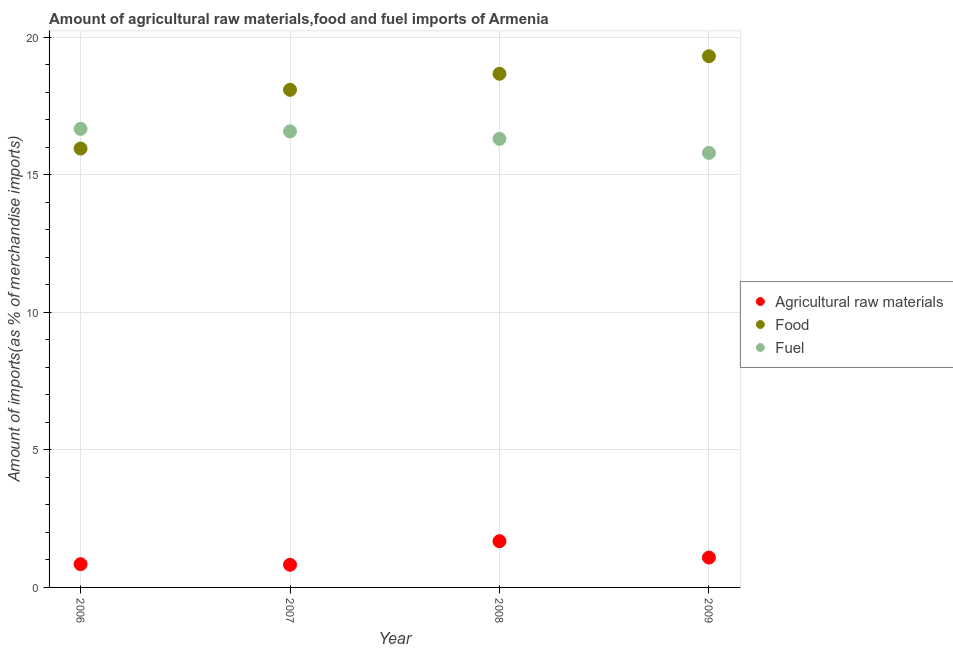Is the number of dotlines equal to the number of legend labels?
Provide a succinct answer. Yes. What is the percentage of food imports in 2008?
Your answer should be very brief. 18.67. Across all years, what is the maximum percentage of food imports?
Offer a terse response. 19.3. Across all years, what is the minimum percentage of food imports?
Give a very brief answer. 15.95. In which year was the percentage of food imports maximum?
Provide a short and direct response. 2009. In which year was the percentage of raw materials imports minimum?
Offer a very short reply. 2007. What is the total percentage of fuel imports in the graph?
Your answer should be compact. 65.33. What is the difference between the percentage of fuel imports in 2007 and that in 2009?
Give a very brief answer. 0.78. What is the difference between the percentage of fuel imports in 2007 and the percentage of raw materials imports in 2006?
Keep it short and to the point. 15.73. What is the average percentage of raw materials imports per year?
Offer a very short reply. 1.11. In the year 2008, what is the difference between the percentage of raw materials imports and percentage of fuel imports?
Keep it short and to the point. -14.62. In how many years, is the percentage of raw materials imports greater than 12 %?
Ensure brevity in your answer.  0. What is the ratio of the percentage of raw materials imports in 2006 to that in 2007?
Ensure brevity in your answer.  1.03. What is the difference between the highest and the second highest percentage of raw materials imports?
Keep it short and to the point. 0.59. What is the difference between the highest and the lowest percentage of fuel imports?
Your response must be concise. 0.87. In how many years, is the percentage of fuel imports greater than the average percentage of fuel imports taken over all years?
Your answer should be compact. 2. Does the percentage of food imports monotonically increase over the years?
Give a very brief answer. Yes. Is the percentage of fuel imports strictly greater than the percentage of food imports over the years?
Offer a very short reply. No. How many dotlines are there?
Make the answer very short. 3. How many years are there in the graph?
Give a very brief answer. 4. Are the values on the major ticks of Y-axis written in scientific E-notation?
Your response must be concise. No. Where does the legend appear in the graph?
Ensure brevity in your answer.  Center right. How many legend labels are there?
Provide a short and direct response. 3. How are the legend labels stacked?
Make the answer very short. Vertical. What is the title of the graph?
Offer a terse response. Amount of agricultural raw materials,food and fuel imports of Armenia. What is the label or title of the Y-axis?
Provide a succinct answer. Amount of imports(as % of merchandise imports). What is the Amount of imports(as % of merchandise imports) of Agricultural raw materials in 2006?
Offer a very short reply. 0.84. What is the Amount of imports(as % of merchandise imports) in Food in 2006?
Provide a short and direct response. 15.95. What is the Amount of imports(as % of merchandise imports) in Fuel in 2006?
Ensure brevity in your answer.  16.66. What is the Amount of imports(as % of merchandise imports) of Agricultural raw materials in 2007?
Provide a succinct answer. 0.82. What is the Amount of imports(as % of merchandise imports) in Food in 2007?
Your answer should be very brief. 18.08. What is the Amount of imports(as % of merchandise imports) in Fuel in 2007?
Your response must be concise. 16.57. What is the Amount of imports(as % of merchandise imports) in Agricultural raw materials in 2008?
Ensure brevity in your answer.  1.68. What is the Amount of imports(as % of merchandise imports) in Food in 2008?
Your answer should be compact. 18.67. What is the Amount of imports(as % of merchandise imports) of Fuel in 2008?
Provide a succinct answer. 16.3. What is the Amount of imports(as % of merchandise imports) in Agricultural raw materials in 2009?
Provide a succinct answer. 1.09. What is the Amount of imports(as % of merchandise imports) in Food in 2009?
Provide a succinct answer. 19.3. What is the Amount of imports(as % of merchandise imports) of Fuel in 2009?
Offer a very short reply. 15.79. Across all years, what is the maximum Amount of imports(as % of merchandise imports) in Agricultural raw materials?
Your answer should be very brief. 1.68. Across all years, what is the maximum Amount of imports(as % of merchandise imports) of Food?
Your answer should be compact. 19.3. Across all years, what is the maximum Amount of imports(as % of merchandise imports) in Fuel?
Your answer should be compact. 16.66. Across all years, what is the minimum Amount of imports(as % of merchandise imports) of Agricultural raw materials?
Keep it short and to the point. 0.82. Across all years, what is the minimum Amount of imports(as % of merchandise imports) of Food?
Your answer should be compact. 15.95. Across all years, what is the minimum Amount of imports(as % of merchandise imports) of Fuel?
Your answer should be very brief. 15.79. What is the total Amount of imports(as % of merchandise imports) of Agricultural raw materials in the graph?
Ensure brevity in your answer.  4.43. What is the total Amount of imports(as % of merchandise imports) in Food in the graph?
Keep it short and to the point. 72. What is the total Amount of imports(as % of merchandise imports) in Fuel in the graph?
Give a very brief answer. 65.33. What is the difference between the Amount of imports(as % of merchandise imports) of Agricultural raw materials in 2006 and that in 2007?
Ensure brevity in your answer.  0.02. What is the difference between the Amount of imports(as % of merchandise imports) in Food in 2006 and that in 2007?
Your answer should be compact. -2.13. What is the difference between the Amount of imports(as % of merchandise imports) in Fuel in 2006 and that in 2007?
Keep it short and to the point. 0.09. What is the difference between the Amount of imports(as % of merchandise imports) in Agricultural raw materials in 2006 and that in 2008?
Your answer should be compact. -0.84. What is the difference between the Amount of imports(as % of merchandise imports) in Food in 2006 and that in 2008?
Offer a very short reply. -2.72. What is the difference between the Amount of imports(as % of merchandise imports) in Fuel in 2006 and that in 2008?
Offer a terse response. 0.36. What is the difference between the Amount of imports(as % of merchandise imports) in Agricultural raw materials in 2006 and that in 2009?
Make the answer very short. -0.24. What is the difference between the Amount of imports(as % of merchandise imports) in Food in 2006 and that in 2009?
Give a very brief answer. -3.35. What is the difference between the Amount of imports(as % of merchandise imports) in Fuel in 2006 and that in 2009?
Your answer should be compact. 0.87. What is the difference between the Amount of imports(as % of merchandise imports) in Agricultural raw materials in 2007 and that in 2008?
Provide a short and direct response. -0.86. What is the difference between the Amount of imports(as % of merchandise imports) in Food in 2007 and that in 2008?
Your answer should be very brief. -0.58. What is the difference between the Amount of imports(as % of merchandise imports) in Fuel in 2007 and that in 2008?
Provide a short and direct response. 0.27. What is the difference between the Amount of imports(as % of merchandise imports) in Agricultural raw materials in 2007 and that in 2009?
Your answer should be compact. -0.26. What is the difference between the Amount of imports(as % of merchandise imports) of Food in 2007 and that in 2009?
Offer a terse response. -1.22. What is the difference between the Amount of imports(as % of merchandise imports) of Fuel in 2007 and that in 2009?
Ensure brevity in your answer.  0.78. What is the difference between the Amount of imports(as % of merchandise imports) in Agricultural raw materials in 2008 and that in 2009?
Your answer should be very brief. 0.59. What is the difference between the Amount of imports(as % of merchandise imports) in Food in 2008 and that in 2009?
Provide a short and direct response. -0.64. What is the difference between the Amount of imports(as % of merchandise imports) of Fuel in 2008 and that in 2009?
Provide a succinct answer. 0.51. What is the difference between the Amount of imports(as % of merchandise imports) of Agricultural raw materials in 2006 and the Amount of imports(as % of merchandise imports) of Food in 2007?
Give a very brief answer. -17.24. What is the difference between the Amount of imports(as % of merchandise imports) of Agricultural raw materials in 2006 and the Amount of imports(as % of merchandise imports) of Fuel in 2007?
Make the answer very short. -15.73. What is the difference between the Amount of imports(as % of merchandise imports) in Food in 2006 and the Amount of imports(as % of merchandise imports) in Fuel in 2007?
Keep it short and to the point. -0.62. What is the difference between the Amount of imports(as % of merchandise imports) in Agricultural raw materials in 2006 and the Amount of imports(as % of merchandise imports) in Food in 2008?
Offer a very short reply. -17.82. What is the difference between the Amount of imports(as % of merchandise imports) of Agricultural raw materials in 2006 and the Amount of imports(as % of merchandise imports) of Fuel in 2008?
Ensure brevity in your answer.  -15.46. What is the difference between the Amount of imports(as % of merchandise imports) of Food in 2006 and the Amount of imports(as % of merchandise imports) of Fuel in 2008?
Offer a terse response. -0.35. What is the difference between the Amount of imports(as % of merchandise imports) of Agricultural raw materials in 2006 and the Amount of imports(as % of merchandise imports) of Food in 2009?
Your answer should be very brief. -18.46. What is the difference between the Amount of imports(as % of merchandise imports) in Agricultural raw materials in 2006 and the Amount of imports(as % of merchandise imports) in Fuel in 2009?
Your answer should be very brief. -14.95. What is the difference between the Amount of imports(as % of merchandise imports) in Food in 2006 and the Amount of imports(as % of merchandise imports) in Fuel in 2009?
Your response must be concise. 0.16. What is the difference between the Amount of imports(as % of merchandise imports) in Agricultural raw materials in 2007 and the Amount of imports(as % of merchandise imports) in Food in 2008?
Provide a succinct answer. -17.84. What is the difference between the Amount of imports(as % of merchandise imports) in Agricultural raw materials in 2007 and the Amount of imports(as % of merchandise imports) in Fuel in 2008?
Provide a succinct answer. -15.48. What is the difference between the Amount of imports(as % of merchandise imports) of Food in 2007 and the Amount of imports(as % of merchandise imports) of Fuel in 2008?
Ensure brevity in your answer.  1.78. What is the difference between the Amount of imports(as % of merchandise imports) of Agricultural raw materials in 2007 and the Amount of imports(as % of merchandise imports) of Food in 2009?
Your answer should be compact. -18.48. What is the difference between the Amount of imports(as % of merchandise imports) in Agricultural raw materials in 2007 and the Amount of imports(as % of merchandise imports) in Fuel in 2009?
Give a very brief answer. -14.97. What is the difference between the Amount of imports(as % of merchandise imports) in Food in 2007 and the Amount of imports(as % of merchandise imports) in Fuel in 2009?
Make the answer very short. 2.29. What is the difference between the Amount of imports(as % of merchandise imports) in Agricultural raw materials in 2008 and the Amount of imports(as % of merchandise imports) in Food in 2009?
Give a very brief answer. -17.62. What is the difference between the Amount of imports(as % of merchandise imports) of Agricultural raw materials in 2008 and the Amount of imports(as % of merchandise imports) of Fuel in 2009?
Keep it short and to the point. -14.11. What is the difference between the Amount of imports(as % of merchandise imports) in Food in 2008 and the Amount of imports(as % of merchandise imports) in Fuel in 2009?
Your answer should be very brief. 2.88. What is the average Amount of imports(as % of merchandise imports) of Agricultural raw materials per year?
Your response must be concise. 1.11. What is the average Amount of imports(as % of merchandise imports) in Food per year?
Offer a terse response. 18. What is the average Amount of imports(as % of merchandise imports) in Fuel per year?
Offer a terse response. 16.33. In the year 2006, what is the difference between the Amount of imports(as % of merchandise imports) in Agricultural raw materials and Amount of imports(as % of merchandise imports) in Food?
Give a very brief answer. -15.11. In the year 2006, what is the difference between the Amount of imports(as % of merchandise imports) in Agricultural raw materials and Amount of imports(as % of merchandise imports) in Fuel?
Provide a succinct answer. -15.82. In the year 2006, what is the difference between the Amount of imports(as % of merchandise imports) in Food and Amount of imports(as % of merchandise imports) in Fuel?
Your response must be concise. -0.71. In the year 2007, what is the difference between the Amount of imports(as % of merchandise imports) in Agricultural raw materials and Amount of imports(as % of merchandise imports) in Food?
Offer a terse response. -17.26. In the year 2007, what is the difference between the Amount of imports(as % of merchandise imports) in Agricultural raw materials and Amount of imports(as % of merchandise imports) in Fuel?
Keep it short and to the point. -15.75. In the year 2007, what is the difference between the Amount of imports(as % of merchandise imports) of Food and Amount of imports(as % of merchandise imports) of Fuel?
Your response must be concise. 1.51. In the year 2008, what is the difference between the Amount of imports(as % of merchandise imports) of Agricultural raw materials and Amount of imports(as % of merchandise imports) of Food?
Offer a terse response. -16.99. In the year 2008, what is the difference between the Amount of imports(as % of merchandise imports) of Agricultural raw materials and Amount of imports(as % of merchandise imports) of Fuel?
Offer a very short reply. -14.62. In the year 2008, what is the difference between the Amount of imports(as % of merchandise imports) of Food and Amount of imports(as % of merchandise imports) of Fuel?
Keep it short and to the point. 2.36. In the year 2009, what is the difference between the Amount of imports(as % of merchandise imports) of Agricultural raw materials and Amount of imports(as % of merchandise imports) of Food?
Keep it short and to the point. -18.22. In the year 2009, what is the difference between the Amount of imports(as % of merchandise imports) of Agricultural raw materials and Amount of imports(as % of merchandise imports) of Fuel?
Provide a short and direct response. -14.71. In the year 2009, what is the difference between the Amount of imports(as % of merchandise imports) of Food and Amount of imports(as % of merchandise imports) of Fuel?
Your response must be concise. 3.51. What is the ratio of the Amount of imports(as % of merchandise imports) in Agricultural raw materials in 2006 to that in 2007?
Give a very brief answer. 1.03. What is the ratio of the Amount of imports(as % of merchandise imports) of Food in 2006 to that in 2007?
Offer a very short reply. 0.88. What is the ratio of the Amount of imports(as % of merchandise imports) in Fuel in 2006 to that in 2007?
Your response must be concise. 1.01. What is the ratio of the Amount of imports(as % of merchandise imports) in Agricultural raw materials in 2006 to that in 2008?
Ensure brevity in your answer.  0.5. What is the ratio of the Amount of imports(as % of merchandise imports) in Food in 2006 to that in 2008?
Keep it short and to the point. 0.85. What is the ratio of the Amount of imports(as % of merchandise imports) in Fuel in 2006 to that in 2008?
Provide a succinct answer. 1.02. What is the ratio of the Amount of imports(as % of merchandise imports) of Agricultural raw materials in 2006 to that in 2009?
Your answer should be very brief. 0.78. What is the ratio of the Amount of imports(as % of merchandise imports) in Food in 2006 to that in 2009?
Give a very brief answer. 0.83. What is the ratio of the Amount of imports(as % of merchandise imports) in Fuel in 2006 to that in 2009?
Your answer should be compact. 1.06. What is the ratio of the Amount of imports(as % of merchandise imports) in Agricultural raw materials in 2007 to that in 2008?
Provide a short and direct response. 0.49. What is the ratio of the Amount of imports(as % of merchandise imports) in Food in 2007 to that in 2008?
Ensure brevity in your answer.  0.97. What is the ratio of the Amount of imports(as % of merchandise imports) of Fuel in 2007 to that in 2008?
Your answer should be very brief. 1.02. What is the ratio of the Amount of imports(as % of merchandise imports) of Agricultural raw materials in 2007 to that in 2009?
Give a very brief answer. 0.76. What is the ratio of the Amount of imports(as % of merchandise imports) in Food in 2007 to that in 2009?
Your answer should be compact. 0.94. What is the ratio of the Amount of imports(as % of merchandise imports) of Fuel in 2007 to that in 2009?
Offer a very short reply. 1.05. What is the ratio of the Amount of imports(as % of merchandise imports) of Agricultural raw materials in 2008 to that in 2009?
Provide a short and direct response. 1.55. What is the ratio of the Amount of imports(as % of merchandise imports) in Fuel in 2008 to that in 2009?
Your response must be concise. 1.03. What is the difference between the highest and the second highest Amount of imports(as % of merchandise imports) of Agricultural raw materials?
Provide a short and direct response. 0.59. What is the difference between the highest and the second highest Amount of imports(as % of merchandise imports) of Food?
Offer a terse response. 0.64. What is the difference between the highest and the second highest Amount of imports(as % of merchandise imports) in Fuel?
Ensure brevity in your answer.  0.09. What is the difference between the highest and the lowest Amount of imports(as % of merchandise imports) of Agricultural raw materials?
Give a very brief answer. 0.86. What is the difference between the highest and the lowest Amount of imports(as % of merchandise imports) of Food?
Offer a terse response. 3.35. What is the difference between the highest and the lowest Amount of imports(as % of merchandise imports) in Fuel?
Your answer should be very brief. 0.87. 